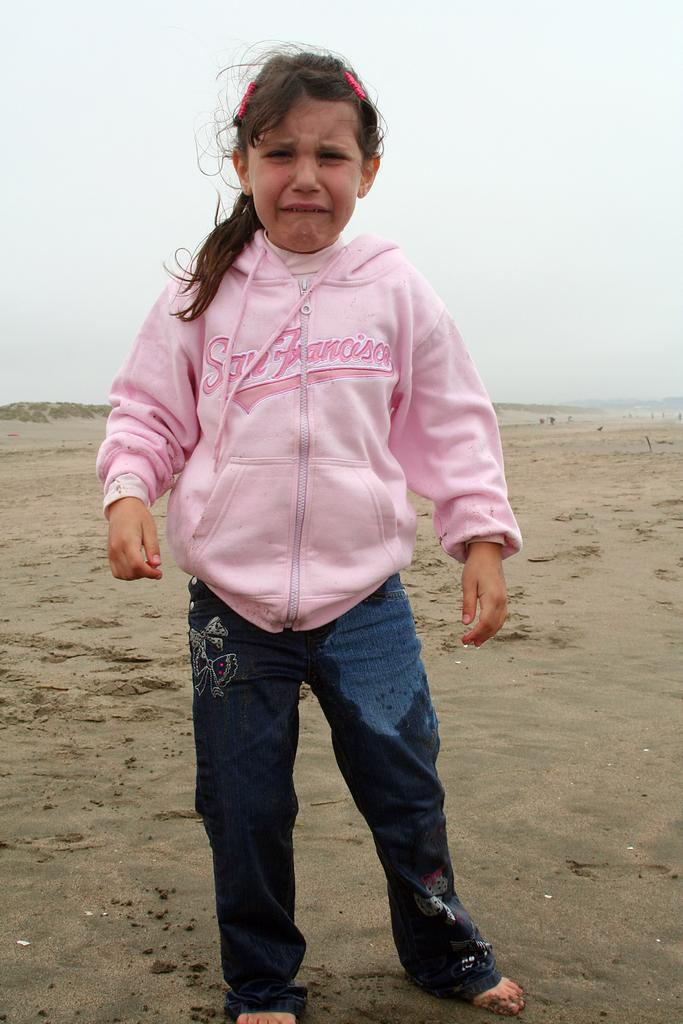Who is present in the image? There is a girl in the image. What is the girl doing in the image? The girl is crying in the image. What type of terrain is visible in the image? There is sand in the image. What is the condition of the sky in the image? The sky is clear in the image. What type of bean is present in the image? There are no beans present in the image. Is the girl wearing a crown in the image? There is no crown visible in the image. 